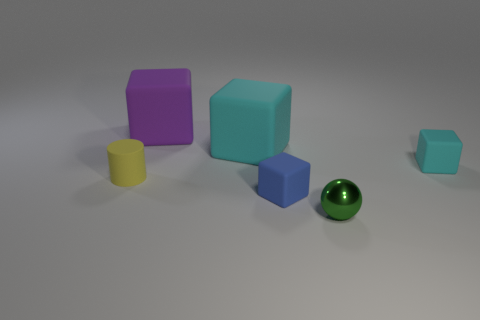How many other things are there of the same shape as the large purple object?
Your answer should be compact. 3. How many tiny green objects are on the right side of the yellow rubber thing?
Provide a succinct answer. 1. Are there fewer big purple objects that are to the right of the small cyan rubber cube than blue matte cubes that are behind the blue rubber object?
Your response must be concise. No. What is the shape of the cyan object that is behind the tiny block that is behind the tiny rubber object to the left of the big purple cube?
Ensure brevity in your answer.  Cube. There is a small thing that is behind the tiny shiny sphere and on the right side of the small blue thing; what shape is it?
Ensure brevity in your answer.  Cube. Is there a tiny green cylinder made of the same material as the blue block?
Make the answer very short. No. What color is the large thing left of the big cyan rubber object?
Your answer should be compact. Purple. There is a tiny yellow object; is it the same shape as the rubber thing in front of the yellow matte cylinder?
Ensure brevity in your answer.  No. Is there a tiny shiny sphere of the same color as the rubber cylinder?
Provide a short and direct response. No. What size is the yellow cylinder that is the same material as the purple block?
Offer a very short reply. Small. 